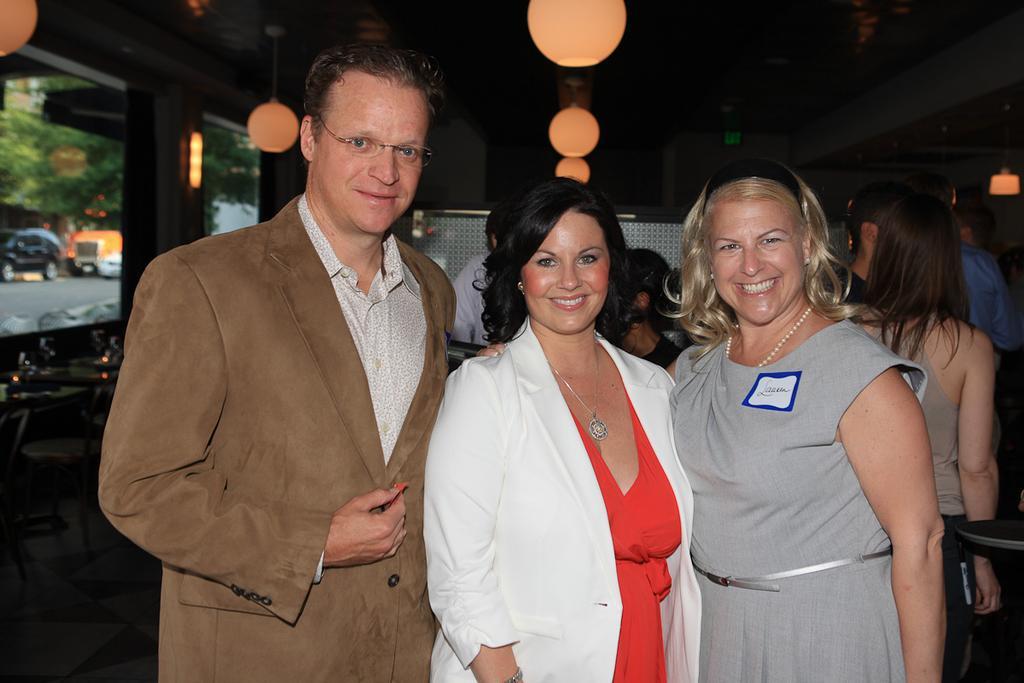Please provide a concise description of this image. In this image I can three persons standing and smiling. Also there are group of people , there are chairs, tables, lights and there is a glass wall. Through the transparent glass I can see vehicles and trees. 